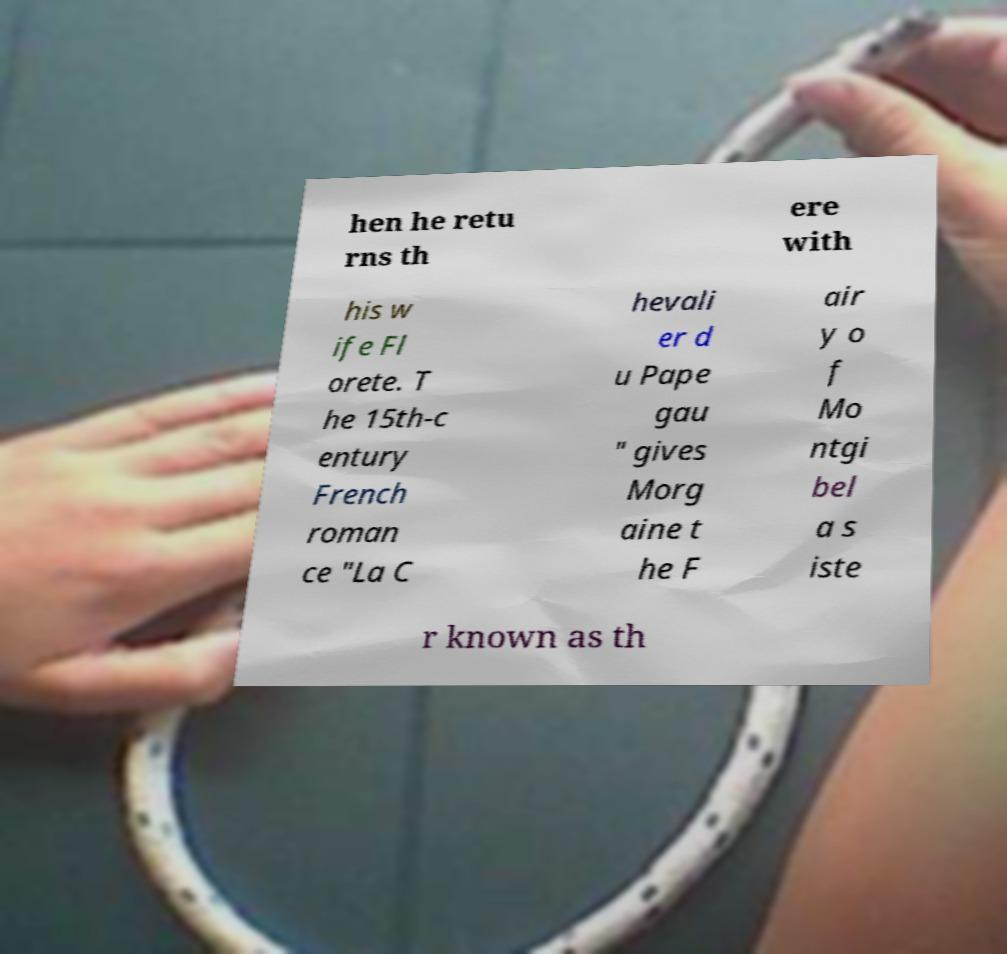Could you assist in decoding the text presented in this image and type it out clearly? hen he retu rns th ere with his w ife Fl orete. T he 15th-c entury French roman ce "La C hevali er d u Pape gau " gives Morg aine t he F air y o f Mo ntgi bel a s iste r known as th 